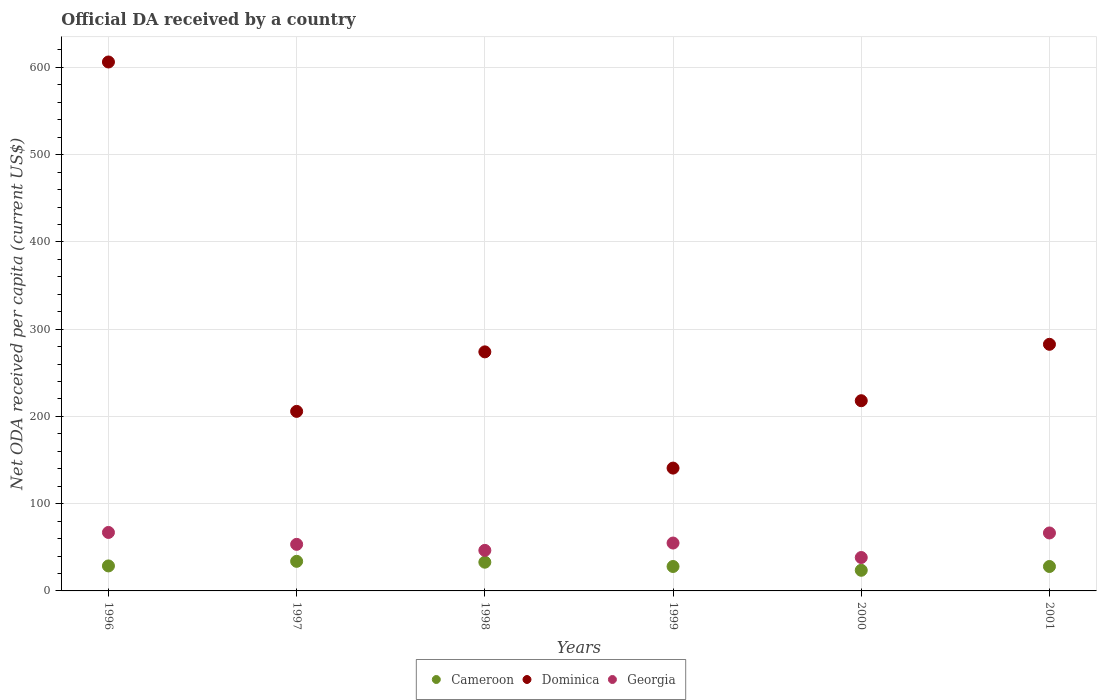How many different coloured dotlines are there?
Ensure brevity in your answer.  3. What is the ODA received in in Cameroon in 1998?
Your response must be concise. 32.92. Across all years, what is the maximum ODA received in in Cameroon?
Make the answer very short. 33.91. Across all years, what is the minimum ODA received in in Georgia?
Your response must be concise. 38.28. In which year was the ODA received in in Georgia minimum?
Provide a short and direct response. 2000. What is the total ODA received in in Georgia in the graph?
Offer a very short reply. 326.45. What is the difference between the ODA received in in Cameroon in 1999 and that in 2001?
Ensure brevity in your answer.  -0.01. What is the difference between the ODA received in in Cameroon in 1998 and the ODA received in in Dominica in 1996?
Offer a terse response. -573.3. What is the average ODA received in in Dominica per year?
Your answer should be compact. 287.9. In the year 2000, what is the difference between the ODA received in in Georgia and ODA received in in Cameroon?
Your answer should be compact. 14.63. What is the ratio of the ODA received in in Georgia in 1996 to that in 1998?
Ensure brevity in your answer.  1.44. Is the difference between the ODA received in in Georgia in 1997 and 1998 greater than the difference between the ODA received in in Cameroon in 1997 and 1998?
Keep it short and to the point. Yes. What is the difference between the highest and the second highest ODA received in in Dominica?
Your answer should be compact. 323.56. What is the difference between the highest and the lowest ODA received in in Georgia?
Provide a short and direct response. 28.74. Is the sum of the ODA received in in Cameroon in 1997 and 1999 greater than the maximum ODA received in in Dominica across all years?
Your answer should be very brief. No. Is it the case that in every year, the sum of the ODA received in in Georgia and ODA received in in Cameroon  is greater than the ODA received in in Dominica?
Provide a succinct answer. No. Does the ODA received in in Cameroon monotonically increase over the years?
Provide a succinct answer. No. How many dotlines are there?
Provide a short and direct response. 3. What is the difference between two consecutive major ticks on the Y-axis?
Give a very brief answer. 100. Are the values on the major ticks of Y-axis written in scientific E-notation?
Your answer should be very brief. No. Does the graph contain any zero values?
Provide a succinct answer. No. Does the graph contain grids?
Keep it short and to the point. Yes. What is the title of the graph?
Give a very brief answer. Official DA received by a country. Does "Netherlands" appear as one of the legend labels in the graph?
Offer a very short reply. No. What is the label or title of the Y-axis?
Make the answer very short. Net ODA received per capita (current US$). What is the Net ODA received per capita (current US$) of Cameroon in 1996?
Offer a very short reply. 28.65. What is the Net ODA received per capita (current US$) in Dominica in 1996?
Offer a very short reply. 606.22. What is the Net ODA received per capita (current US$) of Georgia in 1996?
Your answer should be very brief. 67.02. What is the Net ODA received per capita (current US$) in Cameroon in 1997?
Give a very brief answer. 33.91. What is the Net ODA received per capita (current US$) in Dominica in 1997?
Provide a succinct answer. 205.78. What is the Net ODA received per capita (current US$) in Georgia in 1997?
Your answer should be compact. 53.38. What is the Net ODA received per capita (current US$) in Cameroon in 1998?
Your answer should be compact. 32.92. What is the Net ODA received per capita (current US$) of Dominica in 1998?
Your answer should be compact. 273.99. What is the Net ODA received per capita (current US$) in Georgia in 1998?
Provide a succinct answer. 46.47. What is the Net ODA received per capita (current US$) in Cameroon in 1999?
Provide a short and direct response. 27.99. What is the Net ODA received per capita (current US$) in Dominica in 1999?
Your response must be concise. 140.77. What is the Net ODA received per capita (current US$) of Georgia in 1999?
Your answer should be very brief. 54.88. What is the Net ODA received per capita (current US$) of Cameroon in 2000?
Ensure brevity in your answer.  23.65. What is the Net ODA received per capita (current US$) in Dominica in 2000?
Your answer should be very brief. 218. What is the Net ODA received per capita (current US$) in Georgia in 2000?
Ensure brevity in your answer.  38.28. What is the Net ODA received per capita (current US$) in Cameroon in 2001?
Make the answer very short. 28. What is the Net ODA received per capita (current US$) in Dominica in 2001?
Offer a very short reply. 282.66. What is the Net ODA received per capita (current US$) in Georgia in 2001?
Provide a succinct answer. 66.42. Across all years, what is the maximum Net ODA received per capita (current US$) in Cameroon?
Your response must be concise. 33.91. Across all years, what is the maximum Net ODA received per capita (current US$) of Dominica?
Ensure brevity in your answer.  606.22. Across all years, what is the maximum Net ODA received per capita (current US$) of Georgia?
Offer a terse response. 67.02. Across all years, what is the minimum Net ODA received per capita (current US$) in Cameroon?
Keep it short and to the point. 23.65. Across all years, what is the minimum Net ODA received per capita (current US$) in Dominica?
Offer a very short reply. 140.77. Across all years, what is the minimum Net ODA received per capita (current US$) of Georgia?
Your response must be concise. 38.28. What is the total Net ODA received per capita (current US$) in Cameroon in the graph?
Your response must be concise. 175.12. What is the total Net ODA received per capita (current US$) in Dominica in the graph?
Your answer should be very brief. 1727.41. What is the total Net ODA received per capita (current US$) in Georgia in the graph?
Your answer should be compact. 326.45. What is the difference between the Net ODA received per capita (current US$) in Cameroon in 1996 and that in 1997?
Offer a terse response. -5.26. What is the difference between the Net ODA received per capita (current US$) in Dominica in 1996 and that in 1997?
Your answer should be compact. 400.44. What is the difference between the Net ODA received per capita (current US$) of Georgia in 1996 and that in 1997?
Give a very brief answer. 13.64. What is the difference between the Net ODA received per capita (current US$) of Cameroon in 1996 and that in 1998?
Your answer should be very brief. -4.27. What is the difference between the Net ODA received per capita (current US$) of Dominica in 1996 and that in 1998?
Keep it short and to the point. 332.23. What is the difference between the Net ODA received per capita (current US$) in Georgia in 1996 and that in 1998?
Give a very brief answer. 20.55. What is the difference between the Net ODA received per capita (current US$) in Cameroon in 1996 and that in 1999?
Make the answer very short. 0.66. What is the difference between the Net ODA received per capita (current US$) of Dominica in 1996 and that in 1999?
Provide a succinct answer. 465.45. What is the difference between the Net ODA received per capita (current US$) of Georgia in 1996 and that in 1999?
Give a very brief answer. 12.14. What is the difference between the Net ODA received per capita (current US$) in Cameroon in 1996 and that in 2000?
Your answer should be very brief. 5. What is the difference between the Net ODA received per capita (current US$) of Dominica in 1996 and that in 2000?
Make the answer very short. 388.22. What is the difference between the Net ODA received per capita (current US$) in Georgia in 1996 and that in 2000?
Ensure brevity in your answer.  28.74. What is the difference between the Net ODA received per capita (current US$) of Cameroon in 1996 and that in 2001?
Offer a terse response. 0.65. What is the difference between the Net ODA received per capita (current US$) in Dominica in 1996 and that in 2001?
Offer a very short reply. 323.56. What is the difference between the Net ODA received per capita (current US$) in Georgia in 1996 and that in 2001?
Offer a very short reply. 0.6. What is the difference between the Net ODA received per capita (current US$) of Cameroon in 1997 and that in 1998?
Provide a succinct answer. 0.99. What is the difference between the Net ODA received per capita (current US$) in Dominica in 1997 and that in 1998?
Your answer should be very brief. -68.21. What is the difference between the Net ODA received per capita (current US$) in Georgia in 1997 and that in 1998?
Your answer should be very brief. 6.91. What is the difference between the Net ODA received per capita (current US$) in Cameroon in 1997 and that in 1999?
Offer a terse response. 5.91. What is the difference between the Net ODA received per capita (current US$) of Dominica in 1997 and that in 1999?
Your response must be concise. 65.01. What is the difference between the Net ODA received per capita (current US$) in Georgia in 1997 and that in 1999?
Your answer should be compact. -1.5. What is the difference between the Net ODA received per capita (current US$) of Cameroon in 1997 and that in 2000?
Make the answer very short. 10.25. What is the difference between the Net ODA received per capita (current US$) in Dominica in 1997 and that in 2000?
Ensure brevity in your answer.  -12.22. What is the difference between the Net ODA received per capita (current US$) of Georgia in 1997 and that in 2000?
Make the answer very short. 15.09. What is the difference between the Net ODA received per capita (current US$) in Cameroon in 1997 and that in 2001?
Your answer should be compact. 5.91. What is the difference between the Net ODA received per capita (current US$) of Dominica in 1997 and that in 2001?
Offer a terse response. -76.88. What is the difference between the Net ODA received per capita (current US$) of Georgia in 1997 and that in 2001?
Ensure brevity in your answer.  -13.04. What is the difference between the Net ODA received per capita (current US$) of Cameroon in 1998 and that in 1999?
Your answer should be compact. 4.92. What is the difference between the Net ODA received per capita (current US$) of Dominica in 1998 and that in 1999?
Offer a very short reply. 133.22. What is the difference between the Net ODA received per capita (current US$) of Georgia in 1998 and that in 1999?
Offer a terse response. -8.41. What is the difference between the Net ODA received per capita (current US$) in Cameroon in 1998 and that in 2000?
Your answer should be very brief. 9.26. What is the difference between the Net ODA received per capita (current US$) in Dominica in 1998 and that in 2000?
Your answer should be compact. 55.99. What is the difference between the Net ODA received per capita (current US$) in Georgia in 1998 and that in 2000?
Keep it short and to the point. 8.19. What is the difference between the Net ODA received per capita (current US$) of Cameroon in 1998 and that in 2001?
Provide a short and direct response. 4.92. What is the difference between the Net ODA received per capita (current US$) in Dominica in 1998 and that in 2001?
Offer a very short reply. -8.67. What is the difference between the Net ODA received per capita (current US$) of Georgia in 1998 and that in 2001?
Offer a very short reply. -19.95. What is the difference between the Net ODA received per capita (current US$) in Cameroon in 1999 and that in 2000?
Give a very brief answer. 4.34. What is the difference between the Net ODA received per capita (current US$) in Dominica in 1999 and that in 2000?
Ensure brevity in your answer.  -77.23. What is the difference between the Net ODA received per capita (current US$) of Georgia in 1999 and that in 2000?
Make the answer very short. 16.59. What is the difference between the Net ODA received per capita (current US$) in Cameroon in 1999 and that in 2001?
Give a very brief answer. -0.01. What is the difference between the Net ODA received per capita (current US$) of Dominica in 1999 and that in 2001?
Your answer should be very brief. -141.89. What is the difference between the Net ODA received per capita (current US$) in Georgia in 1999 and that in 2001?
Offer a very short reply. -11.54. What is the difference between the Net ODA received per capita (current US$) of Cameroon in 2000 and that in 2001?
Offer a very short reply. -4.35. What is the difference between the Net ODA received per capita (current US$) of Dominica in 2000 and that in 2001?
Your answer should be very brief. -64.66. What is the difference between the Net ODA received per capita (current US$) of Georgia in 2000 and that in 2001?
Keep it short and to the point. -28.14. What is the difference between the Net ODA received per capita (current US$) of Cameroon in 1996 and the Net ODA received per capita (current US$) of Dominica in 1997?
Your response must be concise. -177.13. What is the difference between the Net ODA received per capita (current US$) in Cameroon in 1996 and the Net ODA received per capita (current US$) in Georgia in 1997?
Ensure brevity in your answer.  -24.73. What is the difference between the Net ODA received per capita (current US$) in Dominica in 1996 and the Net ODA received per capita (current US$) in Georgia in 1997?
Ensure brevity in your answer.  552.84. What is the difference between the Net ODA received per capita (current US$) in Cameroon in 1996 and the Net ODA received per capita (current US$) in Dominica in 1998?
Provide a short and direct response. -245.34. What is the difference between the Net ODA received per capita (current US$) in Cameroon in 1996 and the Net ODA received per capita (current US$) in Georgia in 1998?
Keep it short and to the point. -17.82. What is the difference between the Net ODA received per capita (current US$) of Dominica in 1996 and the Net ODA received per capita (current US$) of Georgia in 1998?
Offer a very short reply. 559.75. What is the difference between the Net ODA received per capita (current US$) of Cameroon in 1996 and the Net ODA received per capita (current US$) of Dominica in 1999?
Ensure brevity in your answer.  -112.12. What is the difference between the Net ODA received per capita (current US$) of Cameroon in 1996 and the Net ODA received per capita (current US$) of Georgia in 1999?
Your answer should be very brief. -26.23. What is the difference between the Net ODA received per capita (current US$) of Dominica in 1996 and the Net ODA received per capita (current US$) of Georgia in 1999?
Your response must be concise. 551.34. What is the difference between the Net ODA received per capita (current US$) of Cameroon in 1996 and the Net ODA received per capita (current US$) of Dominica in 2000?
Your response must be concise. -189.35. What is the difference between the Net ODA received per capita (current US$) in Cameroon in 1996 and the Net ODA received per capita (current US$) in Georgia in 2000?
Keep it short and to the point. -9.63. What is the difference between the Net ODA received per capita (current US$) in Dominica in 1996 and the Net ODA received per capita (current US$) in Georgia in 2000?
Your answer should be compact. 567.93. What is the difference between the Net ODA received per capita (current US$) of Cameroon in 1996 and the Net ODA received per capita (current US$) of Dominica in 2001?
Offer a terse response. -254.01. What is the difference between the Net ODA received per capita (current US$) in Cameroon in 1996 and the Net ODA received per capita (current US$) in Georgia in 2001?
Ensure brevity in your answer.  -37.77. What is the difference between the Net ODA received per capita (current US$) of Dominica in 1996 and the Net ODA received per capita (current US$) of Georgia in 2001?
Keep it short and to the point. 539.8. What is the difference between the Net ODA received per capita (current US$) of Cameroon in 1997 and the Net ODA received per capita (current US$) of Dominica in 1998?
Your answer should be very brief. -240.08. What is the difference between the Net ODA received per capita (current US$) of Cameroon in 1997 and the Net ODA received per capita (current US$) of Georgia in 1998?
Offer a very short reply. -12.56. What is the difference between the Net ODA received per capita (current US$) of Dominica in 1997 and the Net ODA received per capita (current US$) of Georgia in 1998?
Your response must be concise. 159.31. What is the difference between the Net ODA received per capita (current US$) in Cameroon in 1997 and the Net ODA received per capita (current US$) in Dominica in 1999?
Give a very brief answer. -106.86. What is the difference between the Net ODA received per capita (current US$) in Cameroon in 1997 and the Net ODA received per capita (current US$) in Georgia in 1999?
Provide a short and direct response. -20.97. What is the difference between the Net ODA received per capita (current US$) in Dominica in 1997 and the Net ODA received per capita (current US$) in Georgia in 1999?
Your answer should be compact. 150.9. What is the difference between the Net ODA received per capita (current US$) of Cameroon in 1997 and the Net ODA received per capita (current US$) of Dominica in 2000?
Ensure brevity in your answer.  -184.09. What is the difference between the Net ODA received per capita (current US$) in Cameroon in 1997 and the Net ODA received per capita (current US$) in Georgia in 2000?
Provide a succinct answer. -4.38. What is the difference between the Net ODA received per capita (current US$) in Dominica in 1997 and the Net ODA received per capita (current US$) in Georgia in 2000?
Provide a succinct answer. 167.49. What is the difference between the Net ODA received per capita (current US$) of Cameroon in 1997 and the Net ODA received per capita (current US$) of Dominica in 2001?
Your answer should be compact. -248.75. What is the difference between the Net ODA received per capita (current US$) in Cameroon in 1997 and the Net ODA received per capita (current US$) in Georgia in 2001?
Provide a short and direct response. -32.51. What is the difference between the Net ODA received per capita (current US$) of Dominica in 1997 and the Net ODA received per capita (current US$) of Georgia in 2001?
Offer a very short reply. 139.36. What is the difference between the Net ODA received per capita (current US$) of Cameroon in 1998 and the Net ODA received per capita (current US$) of Dominica in 1999?
Provide a succinct answer. -107.85. What is the difference between the Net ODA received per capita (current US$) in Cameroon in 1998 and the Net ODA received per capita (current US$) in Georgia in 1999?
Your answer should be compact. -21.96. What is the difference between the Net ODA received per capita (current US$) in Dominica in 1998 and the Net ODA received per capita (current US$) in Georgia in 1999?
Provide a succinct answer. 219.11. What is the difference between the Net ODA received per capita (current US$) in Cameroon in 1998 and the Net ODA received per capita (current US$) in Dominica in 2000?
Offer a terse response. -185.08. What is the difference between the Net ODA received per capita (current US$) of Cameroon in 1998 and the Net ODA received per capita (current US$) of Georgia in 2000?
Ensure brevity in your answer.  -5.37. What is the difference between the Net ODA received per capita (current US$) in Dominica in 1998 and the Net ODA received per capita (current US$) in Georgia in 2000?
Make the answer very short. 235.7. What is the difference between the Net ODA received per capita (current US$) in Cameroon in 1998 and the Net ODA received per capita (current US$) in Dominica in 2001?
Your answer should be compact. -249.74. What is the difference between the Net ODA received per capita (current US$) of Cameroon in 1998 and the Net ODA received per capita (current US$) of Georgia in 2001?
Make the answer very short. -33.51. What is the difference between the Net ODA received per capita (current US$) in Dominica in 1998 and the Net ODA received per capita (current US$) in Georgia in 2001?
Your answer should be compact. 207.57. What is the difference between the Net ODA received per capita (current US$) of Cameroon in 1999 and the Net ODA received per capita (current US$) of Dominica in 2000?
Make the answer very short. -190.01. What is the difference between the Net ODA received per capita (current US$) of Cameroon in 1999 and the Net ODA received per capita (current US$) of Georgia in 2000?
Provide a succinct answer. -10.29. What is the difference between the Net ODA received per capita (current US$) in Dominica in 1999 and the Net ODA received per capita (current US$) in Georgia in 2000?
Keep it short and to the point. 102.48. What is the difference between the Net ODA received per capita (current US$) in Cameroon in 1999 and the Net ODA received per capita (current US$) in Dominica in 2001?
Provide a succinct answer. -254.67. What is the difference between the Net ODA received per capita (current US$) of Cameroon in 1999 and the Net ODA received per capita (current US$) of Georgia in 2001?
Provide a short and direct response. -38.43. What is the difference between the Net ODA received per capita (current US$) of Dominica in 1999 and the Net ODA received per capita (current US$) of Georgia in 2001?
Ensure brevity in your answer.  74.35. What is the difference between the Net ODA received per capita (current US$) of Cameroon in 2000 and the Net ODA received per capita (current US$) of Dominica in 2001?
Keep it short and to the point. -259.01. What is the difference between the Net ODA received per capita (current US$) of Cameroon in 2000 and the Net ODA received per capita (current US$) of Georgia in 2001?
Make the answer very short. -42.77. What is the difference between the Net ODA received per capita (current US$) of Dominica in 2000 and the Net ODA received per capita (current US$) of Georgia in 2001?
Provide a short and direct response. 151.58. What is the average Net ODA received per capita (current US$) in Cameroon per year?
Provide a short and direct response. 29.19. What is the average Net ODA received per capita (current US$) of Dominica per year?
Provide a short and direct response. 287.9. What is the average Net ODA received per capita (current US$) of Georgia per year?
Ensure brevity in your answer.  54.41. In the year 1996, what is the difference between the Net ODA received per capita (current US$) in Cameroon and Net ODA received per capita (current US$) in Dominica?
Ensure brevity in your answer.  -577.57. In the year 1996, what is the difference between the Net ODA received per capita (current US$) in Cameroon and Net ODA received per capita (current US$) in Georgia?
Give a very brief answer. -38.37. In the year 1996, what is the difference between the Net ODA received per capita (current US$) of Dominica and Net ODA received per capita (current US$) of Georgia?
Ensure brevity in your answer.  539.2. In the year 1997, what is the difference between the Net ODA received per capita (current US$) of Cameroon and Net ODA received per capita (current US$) of Dominica?
Make the answer very short. -171.87. In the year 1997, what is the difference between the Net ODA received per capita (current US$) in Cameroon and Net ODA received per capita (current US$) in Georgia?
Your response must be concise. -19.47. In the year 1997, what is the difference between the Net ODA received per capita (current US$) in Dominica and Net ODA received per capita (current US$) in Georgia?
Your answer should be compact. 152.4. In the year 1998, what is the difference between the Net ODA received per capita (current US$) in Cameroon and Net ODA received per capita (current US$) in Dominica?
Give a very brief answer. -241.07. In the year 1998, what is the difference between the Net ODA received per capita (current US$) of Cameroon and Net ODA received per capita (current US$) of Georgia?
Your response must be concise. -13.55. In the year 1998, what is the difference between the Net ODA received per capita (current US$) in Dominica and Net ODA received per capita (current US$) in Georgia?
Ensure brevity in your answer.  227.52. In the year 1999, what is the difference between the Net ODA received per capita (current US$) in Cameroon and Net ODA received per capita (current US$) in Dominica?
Your answer should be very brief. -112.78. In the year 1999, what is the difference between the Net ODA received per capita (current US$) of Cameroon and Net ODA received per capita (current US$) of Georgia?
Give a very brief answer. -26.88. In the year 1999, what is the difference between the Net ODA received per capita (current US$) of Dominica and Net ODA received per capita (current US$) of Georgia?
Provide a succinct answer. 85.89. In the year 2000, what is the difference between the Net ODA received per capita (current US$) in Cameroon and Net ODA received per capita (current US$) in Dominica?
Provide a succinct answer. -194.35. In the year 2000, what is the difference between the Net ODA received per capita (current US$) of Cameroon and Net ODA received per capita (current US$) of Georgia?
Your answer should be very brief. -14.63. In the year 2000, what is the difference between the Net ODA received per capita (current US$) of Dominica and Net ODA received per capita (current US$) of Georgia?
Your answer should be compact. 179.72. In the year 2001, what is the difference between the Net ODA received per capita (current US$) of Cameroon and Net ODA received per capita (current US$) of Dominica?
Your answer should be compact. -254.66. In the year 2001, what is the difference between the Net ODA received per capita (current US$) of Cameroon and Net ODA received per capita (current US$) of Georgia?
Provide a succinct answer. -38.42. In the year 2001, what is the difference between the Net ODA received per capita (current US$) of Dominica and Net ODA received per capita (current US$) of Georgia?
Keep it short and to the point. 216.24. What is the ratio of the Net ODA received per capita (current US$) of Cameroon in 1996 to that in 1997?
Offer a terse response. 0.84. What is the ratio of the Net ODA received per capita (current US$) in Dominica in 1996 to that in 1997?
Your answer should be compact. 2.95. What is the ratio of the Net ODA received per capita (current US$) in Georgia in 1996 to that in 1997?
Give a very brief answer. 1.26. What is the ratio of the Net ODA received per capita (current US$) of Cameroon in 1996 to that in 1998?
Offer a very short reply. 0.87. What is the ratio of the Net ODA received per capita (current US$) in Dominica in 1996 to that in 1998?
Your response must be concise. 2.21. What is the ratio of the Net ODA received per capita (current US$) of Georgia in 1996 to that in 1998?
Make the answer very short. 1.44. What is the ratio of the Net ODA received per capita (current US$) in Cameroon in 1996 to that in 1999?
Keep it short and to the point. 1.02. What is the ratio of the Net ODA received per capita (current US$) of Dominica in 1996 to that in 1999?
Provide a succinct answer. 4.31. What is the ratio of the Net ODA received per capita (current US$) of Georgia in 1996 to that in 1999?
Provide a succinct answer. 1.22. What is the ratio of the Net ODA received per capita (current US$) in Cameroon in 1996 to that in 2000?
Ensure brevity in your answer.  1.21. What is the ratio of the Net ODA received per capita (current US$) of Dominica in 1996 to that in 2000?
Offer a very short reply. 2.78. What is the ratio of the Net ODA received per capita (current US$) of Georgia in 1996 to that in 2000?
Offer a terse response. 1.75. What is the ratio of the Net ODA received per capita (current US$) of Cameroon in 1996 to that in 2001?
Provide a short and direct response. 1.02. What is the ratio of the Net ODA received per capita (current US$) in Dominica in 1996 to that in 2001?
Your response must be concise. 2.14. What is the ratio of the Net ODA received per capita (current US$) of Cameroon in 1997 to that in 1998?
Make the answer very short. 1.03. What is the ratio of the Net ODA received per capita (current US$) in Dominica in 1997 to that in 1998?
Your answer should be compact. 0.75. What is the ratio of the Net ODA received per capita (current US$) in Georgia in 1997 to that in 1998?
Ensure brevity in your answer.  1.15. What is the ratio of the Net ODA received per capita (current US$) of Cameroon in 1997 to that in 1999?
Ensure brevity in your answer.  1.21. What is the ratio of the Net ODA received per capita (current US$) of Dominica in 1997 to that in 1999?
Keep it short and to the point. 1.46. What is the ratio of the Net ODA received per capita (current US$) in Georgia in 1997 to that in 1999?
Your response must be concise. 0.97. What is the ratio of the Net ODA received per capita (current US$) of Cameroon in 1997 to that in 2000?
Provide a succinct answer. 1.43. What is the ratio of the Net ODA received per capita (current US$) of Dominica in 1997 to that in 2000?
Your response must be concise. 0.94. What is the ratio of the Net ODA received per capita (current US$) of Georgia in 1997 to that in 2000?
Provide a short and direct response. 1.39. What is the ratio of the Net ODA received per capita (current US$) of Cameroon in 1997 to that in 2001?
Your answer should be compact. 1.21. What is the ratio of the Net ODA received per capita (current US$) in Dominica in 1997 to that in 2001?
Ensure brevity in your answer.  0.73. What is the ratio of the Net ODA received per capita (current US$) in Georgia in 1997 to that in 2001?
Give a very brief answer. 0.8. What is the ratio of the Net ODA received per capita (current US$) of Cameroon in 1998 to that in 1999?
Make the answer very short. 1.18. What is the ratio of the Net ODA received per capita (current US$) of Dominica in 1998 to that in 1999?
Keep it short and to the point. 1.95. What is the ratio of the Net ODA received per capita (current US$) in Georgia in 1998 to that in 1999?
Keep it short and to the point. 0.85. What is the ratio of the Net ODA received per capita (current US$) of Cameroon in 1998 to that in 2000?
Your response must be concise. 1.39. What is the ratio of the Net ODA received per capita (current US$) in Dominica in 1998 to that in 2000?
Make the answer very short. 1.26. What is the ratio of the Net ODA received per capita (current US$) in Georgia in 1998 to that in 2000?
Keep it short and to the point. 1.21. What is the ratio of the Net ODA received per capita (current US$) in Cameroon in 1998 to that in 2001?
Give a very brief answer. 1.18. What is the ratio of the Net ODA received per capita (current US$) of Dominica in 1998 to that in 2001?
Provide a succinct answer. 0.97. What is the ratio of the Net ODA received per capita (current US$) in Georgia in 1998 to that in 2001?
Your response must be concise. 0.7. What is the ratio of the Net ODA received per capita (current US$) in Cameroon in 1999 to that in 2000?
Give a very brief answer. 1.18. What is the ratio of the Net ODA received per capita (current US$) in Dominica in 1999 to that in 2000?
Ensure brevity in your answer.  0.65. What is the ratio of the Net ODA received per capita (current US$) in Georgia in 1999 to that in 2000?
Your answer should be very brief. 1.43. What is the ratio of the Net ODA received per capita (current US$) of Cameroon in 1999 to that in 2001?
Ensure brevity in your answer.  1. What is the ratio of the Net ODA received per capita (current US$) in Dominica in 1999 to that in 2001?
Ensure brevity in your answer.  0.5. What is the ratio of the Net ODA received per capita (current US$) in Georgia in 1999 to that in 2001?
Your answer should be compact. 0.83. What is the ratio of the Net ODA received per capita (current US$) of Cameroon in 2000 to that in 2001?
Your response must be concise. 0.84. What is the ratio of the Net ODA received per capita (current US$) in Dominica in 2000 to that in 2001?
Keep it short and to the point. 0.77. What is the ratio of the Net ODA received per capita (current US$) of Georgia in 2000 to that in 2001?
Offer a terse response. 0.58. What is the difference between the highest and the second highest Net ODA received per capita (current US$) of Dominica?
Make the answer very short. 323.56. What is the difference between the highest and the second highest Net ODA received per capita (current US$) in Georgia?
Offer a terse response. 0.6. What is the difference between the highest and the lowest Net ODA received per capita (current US$) of Cameroon?
Provide a succinct answer. 10.25. What is the difference between the highest and the lowest Net ODA received per capita (current US$) of Dominica?
Ensure brevity in your answer.  465.45. What is the difference between the highest and the lowest Net ODA received per capita (current US$) in Georgia?
Offer a terse response. 28.74. 